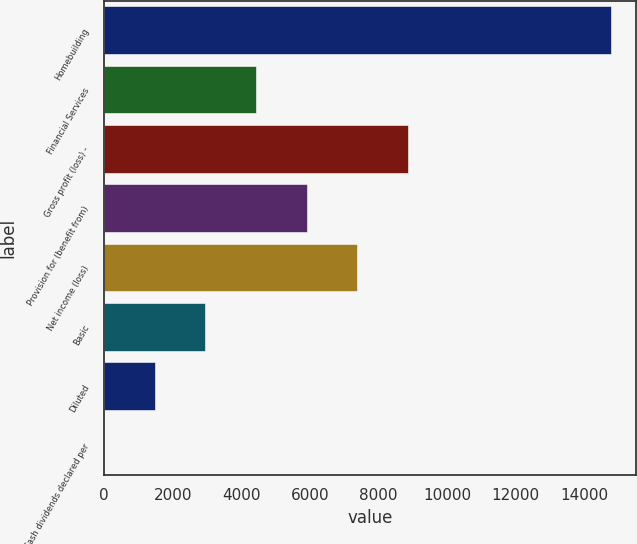<chart> <loc_0><loc_0><loc_500><loc_500><bar_chart><fcel>Homebuilding<fcel>Financial Services<fcel>Gross profit (loss) -<fcel>Provision for (benefit from)<fcel>Net income (loss)<fcel>Basic<fcel>Diluted<fcel>Cash dividends declared per<nl><fcel>14760.5<fcel>4428.47<fcel>8856.5<fcel>5904.48<fcel>7380.49<fcel>2952.46<fcel>1476.45<fcel>0.44<nl></chart> 